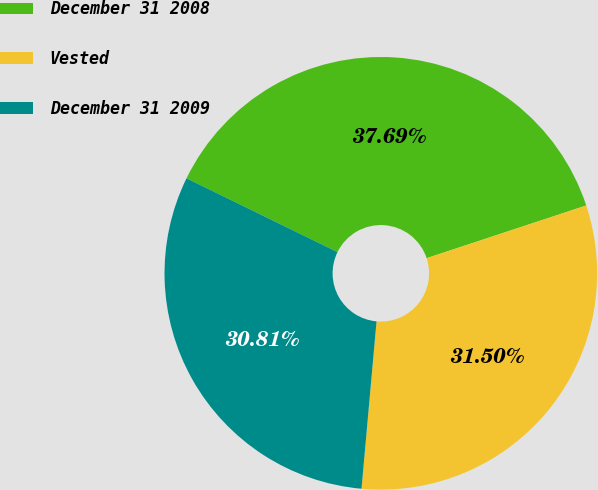Convert chart to OTSL. <chart><loc_0><loc_0><loc_500><loc_500><pie_chart><fcel>December 31 2008<fcel>Vested<fcel>December 31 2009<nl><fcel>37.69%<fcel>31.5%<fcel>30.81%<nl></chart> 